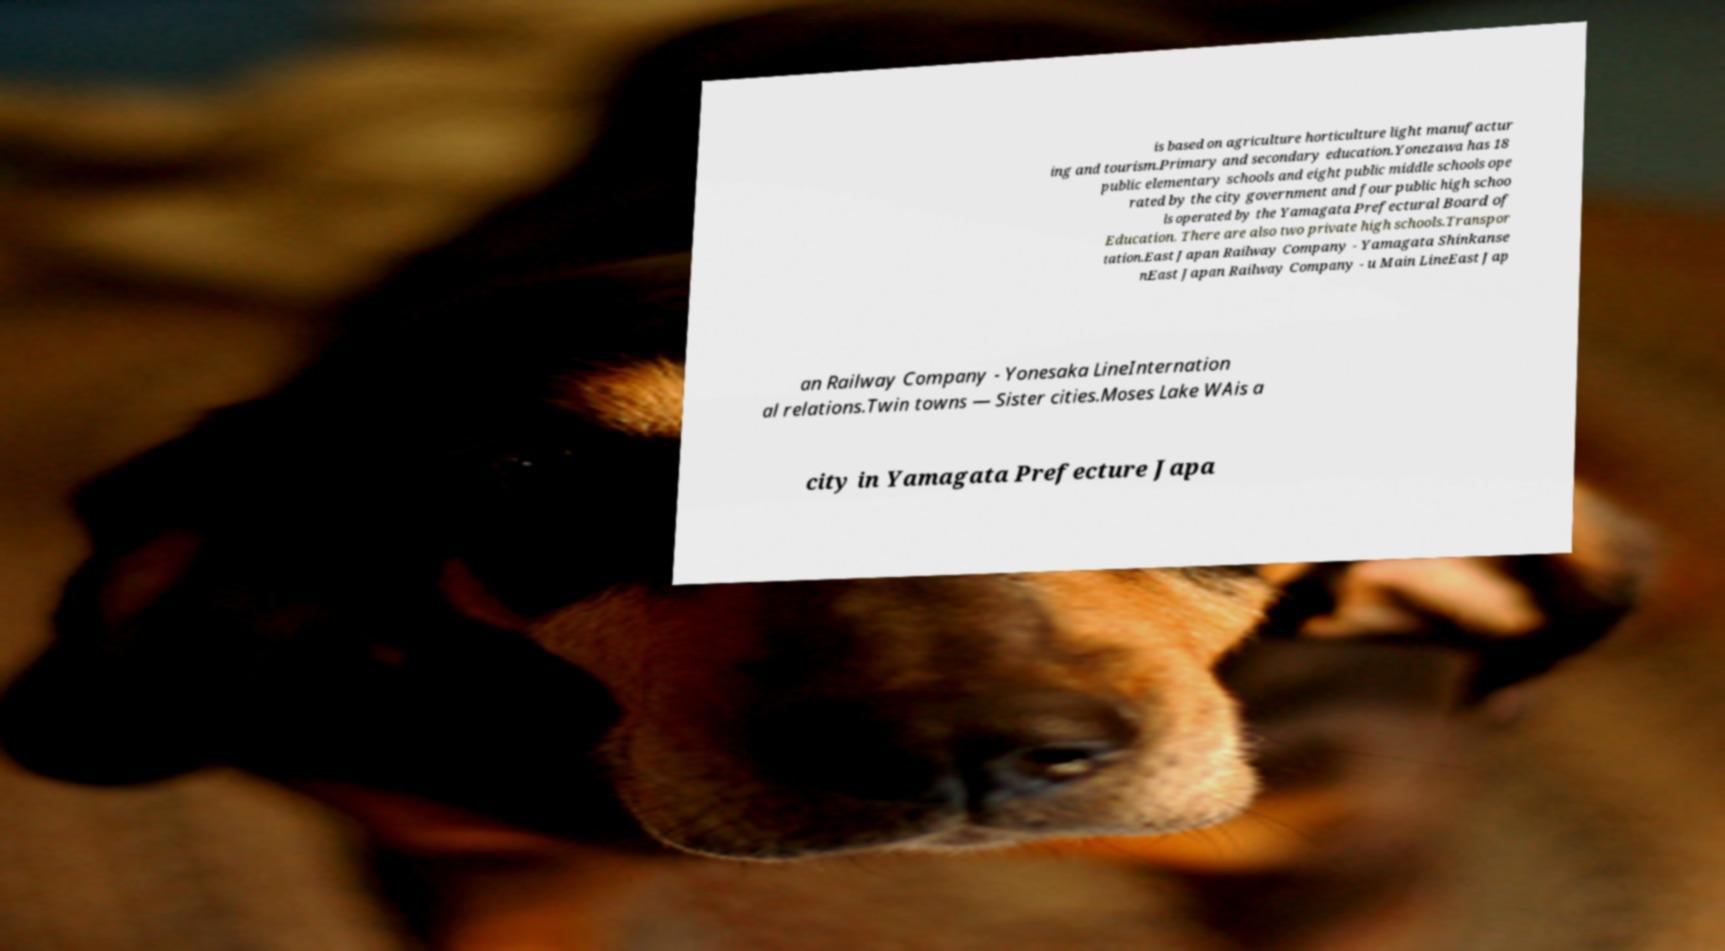Could you extract and type out the text from this image? is based on agriculture horticulture light manufactur ing and tourism.Primary and secondary education.Yonezawa has 18 public elementary schools and eight public middle schools ope rated by the city government and four public high schoo ls operated by the Yamagata Prefectural Board of Education. There are also two private high schools.Transpor tation.East Japan Railway Company - Yamagata Shinkanse nEast Japan Railway Company - u Main LineEast Jap an Railway Company - Yonesaka LineInternation al relations.Twin towns — Sister cities.Moses Lake WAis a city in Yamagata Prefecture Japa 